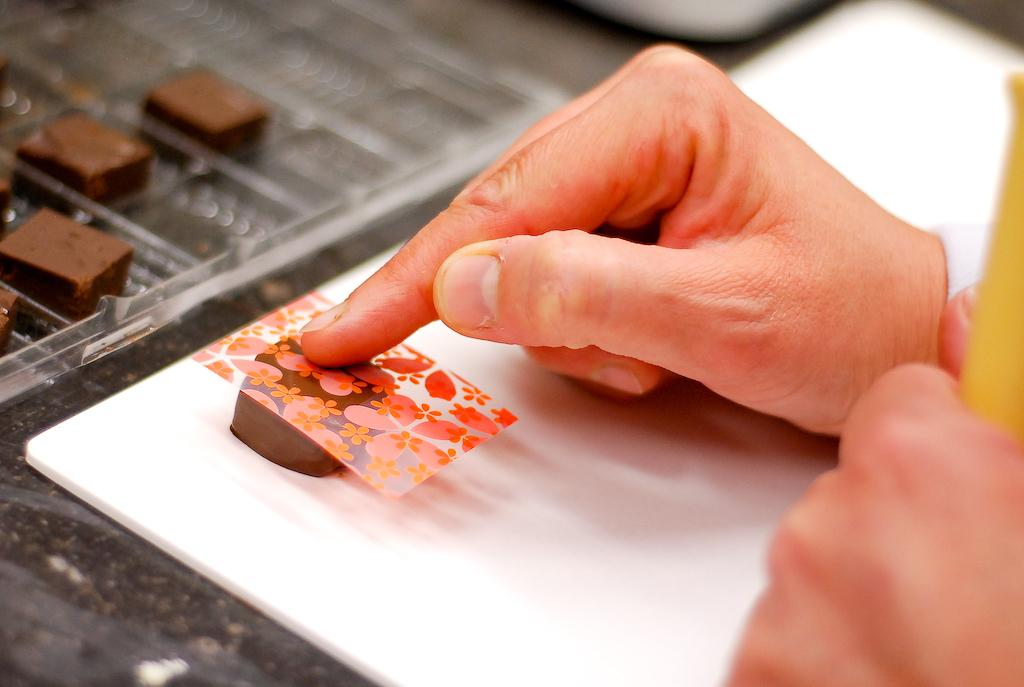What is the person's hand doing in the image? The person's hand is placing a creative cover on chocolate. What else can be seen on the table besides the person's hand? There are chocolates on a tray visible on the table. What is the primary object on the table in the image? The primary object on the table is a tray of chocolates. What direction is the person coughing in the image? There is no person coughing in the image; the person's hand is placing a creative cover on chocolate. What type of scissors are being used to cut the chocolate in the image? There are no scissors present in the image; the person's hand is placing a creative cover on chocolate. 